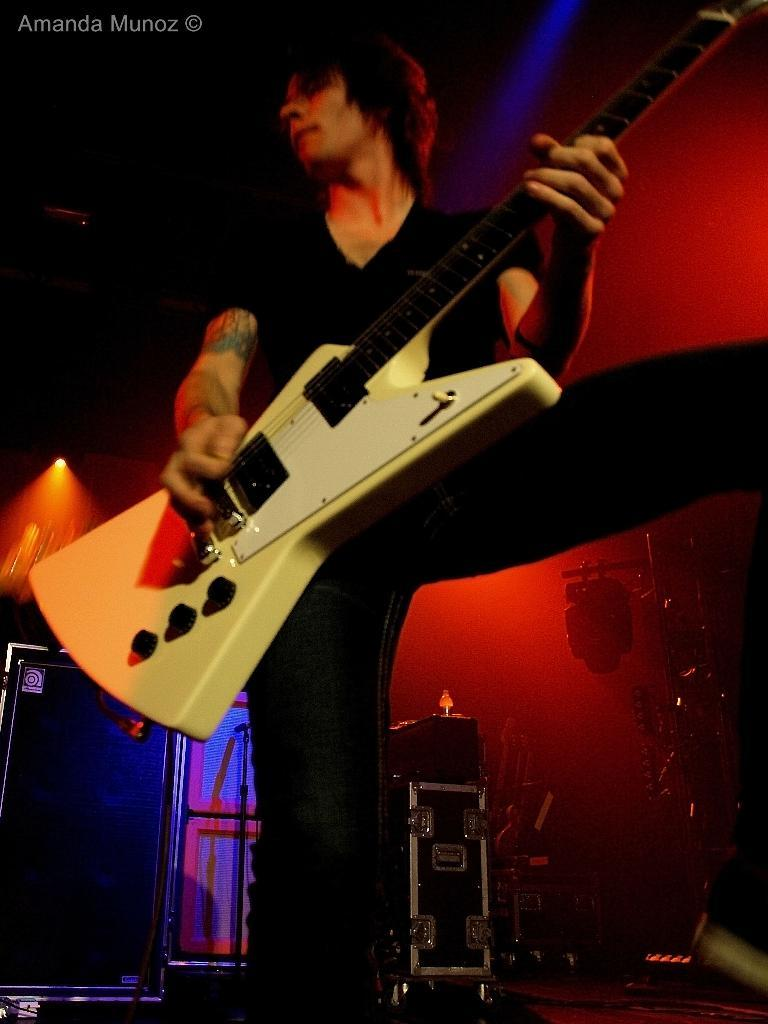What is the man in the image doing? The man is playing a guitar in the image. What objects are behind the man? There are musical instruments and electronic devices behind the man. What is the price of the secretary in the image? There is no secretary present in the image. 